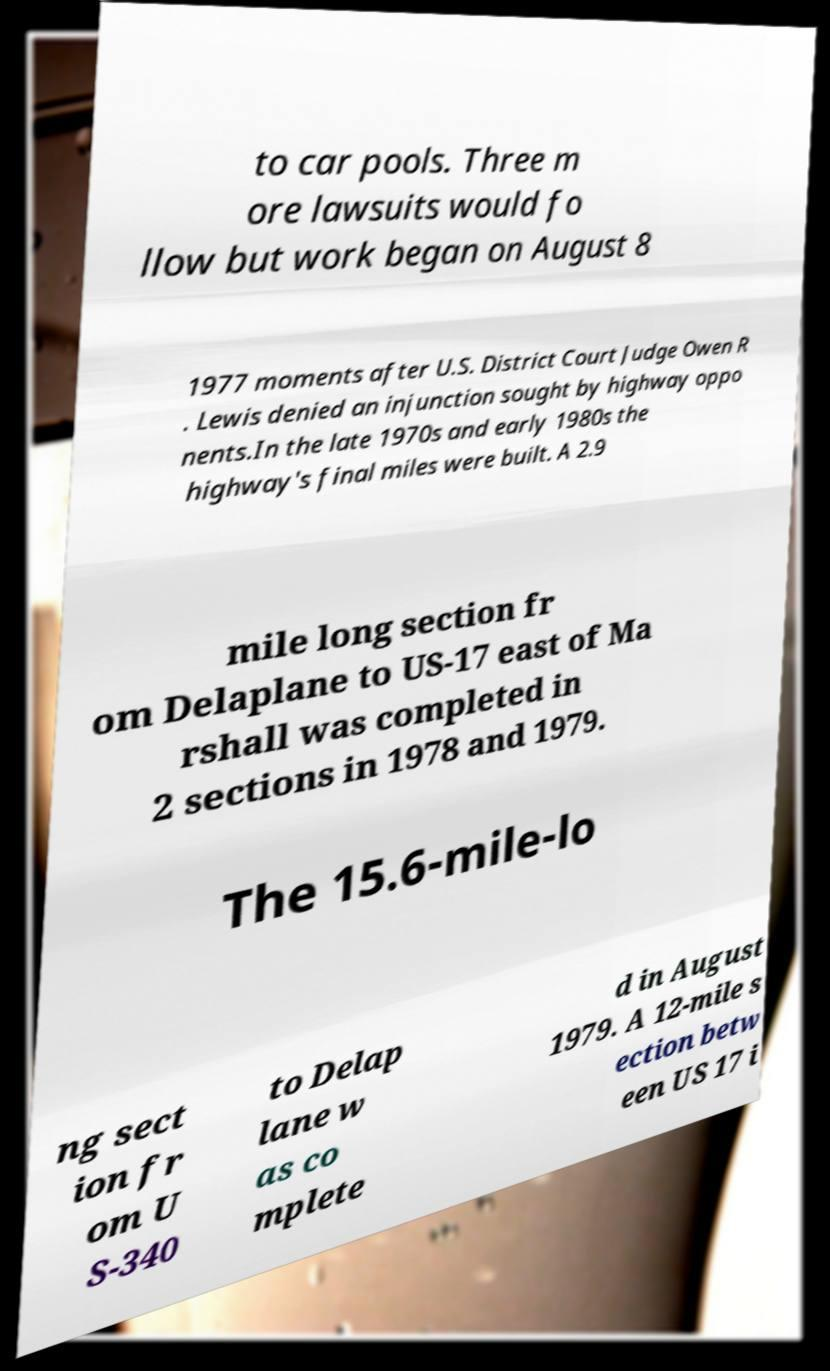Could you assist in decoding the text presented in this image and type it out clearly? to car pools. Three m ore lawsuits would fo llow but work began on August 8 1977 moments after U.S. District Court Judge Owen R . Lewis denied an injunction sought by highway oppo nents.In the late 1970s and early 1980s the highway's final miles were built. A 2.9 mile long section fr om Delaplane to US-17 east of Ma rshall was completed in 2 sections in 1978 and 1979. The 15.6-mile-lo ng sect ion fr om U S-340 to Delap lane w as co mplete d in August 1979. A 12-mile s ection betw een US 17 i 